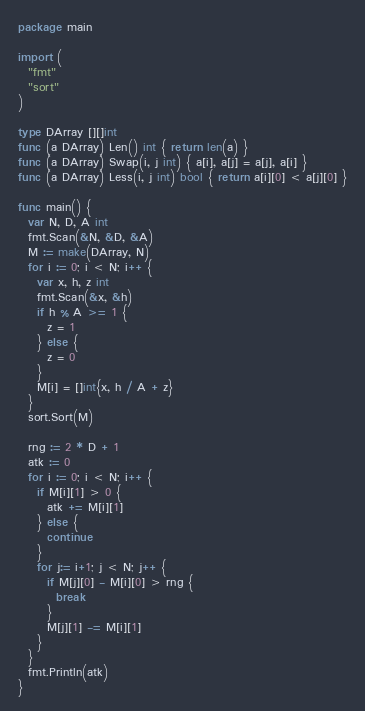Convert code to text. <code><loc_0><loc_0><loc_500><loc_500><_Go_>package main

import (
  "fmt"
  "sort"
)

type DArray [][]int
func (a DArray) Len() int { return len(a) }
func (a DArray) Swap(i, j int) { a[i], a[j] = a[j], a[i] }
func (a DArray) Less(i, j int) bool { return a[i][0] < a[j][0] }

func main() {
  var N, D, A int
  fmt.Scan(&N, &D, &A)
  M := make(DArray, N)
  for i := 0; i < N; i++ {
    var x, h, z int
    fmt.Scan(&x, &h)
    if h % A >= 1 {
      z = 1
    } else {
      z = 0
    }
    M[i] = []int{x, h / A + z}
  }
  sort.Sort(M)

  rng := 2 * D + 1
  atk := 0
  for i := 0; i < N; i++ {
    if M[i][1] > 0 {
      atk += M[i][1]
    } else {
      continue
    }
    for j:= i+1; j < N; j++ {
      if M[j][0] - M[i][0] > rng {
        break
      }
      M[j][1] -= M[i][1]
    }
  }
  fmt.Println(atk)
}</code> 